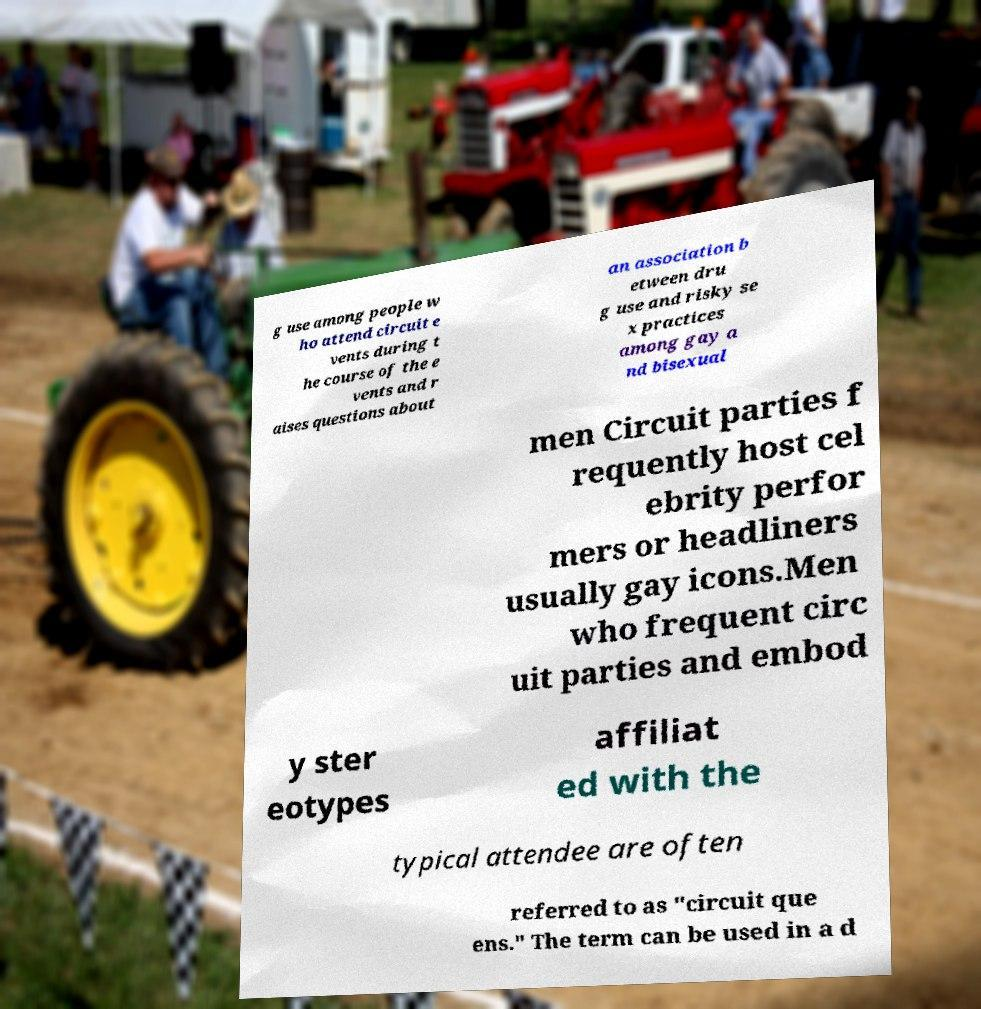I need the written content from this picture converted into text. Can you do that? g use among people w ho attend circuit e vents during t he course of the e vents and r aises questions about an association b etween dru g use and risky se x practices among gay a nd bisexual men Circuit parties f requently host cel ebrity perfor mers or headliners usually gay icons.Men who frequent circ uit parties and embod y ster eotypes affiliat ed with the typical attendee are often referred to as "circuit que ens." The term can be used in a d 